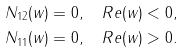Convert formula to latex. <formula><loc_0><loc_0><loc_500><loc_500>& N _ { 1 2 } ( w ) = 0 , \quad R e ( w ) < 0 , \\ & N _ { 1 1 } ( w ) = 0 , \quad R e ( w ) > 0 .</formula> 